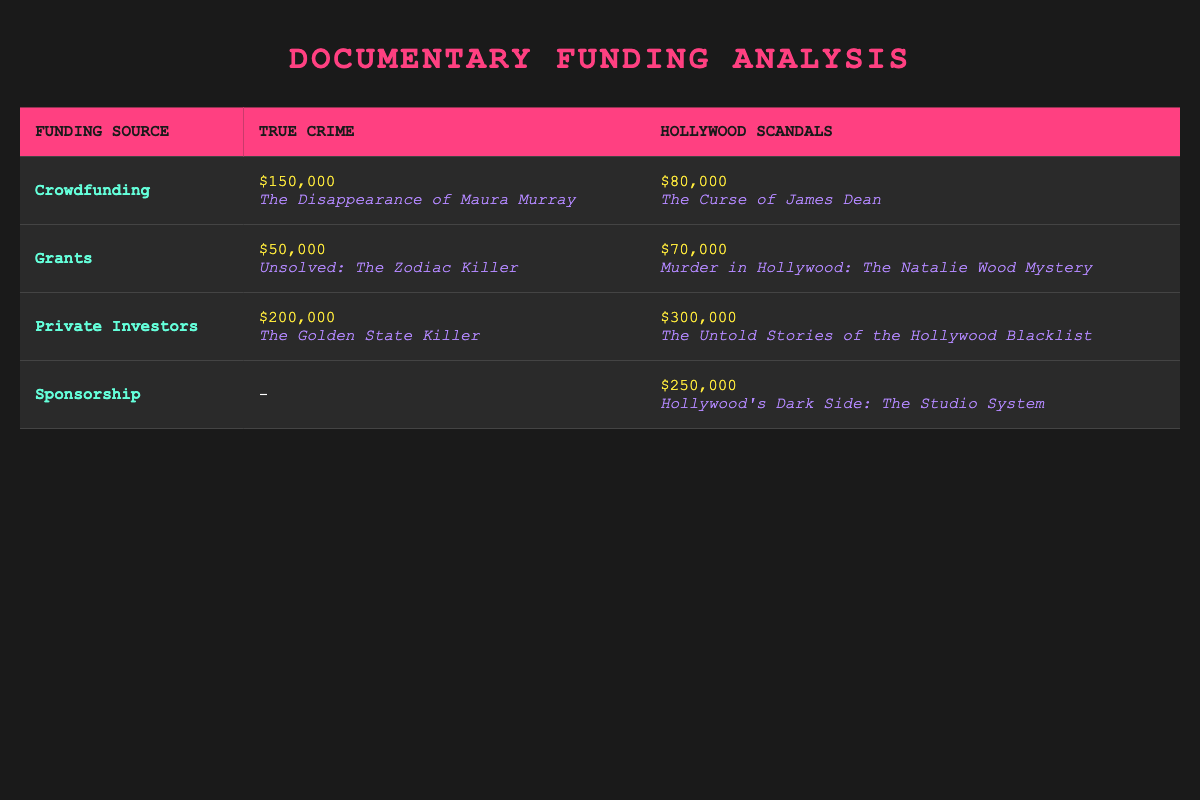What is the total funding received from private investors for true crime documentaries? The funding from private investors for true crime is listed as $200,000 in the table.
Answer: 200000 Which type of funding produced the highest total amount for Hollywood scandal documentaries? Sponsorship contributed $250,000, while private investors contributed $300,000; therefore, private investors produced the highest total amount.
Answer: Private Investors Is there a documentary funded by grants in the true crime category? Yes, the table lists "Unsolved: The Zodiac Killer," which has received $50,000 from grants in the true crime category.
Answer: Yes What is the difference in total funding amounts between crowdfunding for true crime and Hollywood scandals? True crime crowdfunding totals $150,000, and Hollywood scandals crowdfunding totals $80,000; the difference is $150,000 - $80,000 = $70,000.
Answer: 70000 Calculate the average funding amount received from grants across both documentary types. The grants for true crime is $50,000, and for Hollywood scandals is $70,000; they add up to $50,000 + $70,000 = $120,000 over 2 projects, so the average is $120,000 / 2 = $60,000.
Answer: 60000 Which documentary had the highest amount funded overall? The highest funding amount comes from "The Untold Stories of the Hollywood Blacklist" at $300,000, funded by private investors.
Answer: The Untold Stories of the Hollywood Blacklist Was there any documentary that did not receive crowdfunding? Yes, "The Untold Stories of the Hollywood Blacklist" and "Hollywood's Dark Side: The Studio System" were funded by private investors and sponsorship, respectively, and did not receive crowdfunding.
Answer: Yes What is the total funding amount for all Hollywood scandals projects listed in the table? The total funding for Hollywood scandals is $80,000 (crowdfunding) + $70,000 (grants) + $300,000 (private investors) + $250,000 (sponsorship) = $700,000.
Answer: 700000 Which funding source was utilized for the documentary "The Golden State Killer"? The documentary "The Golden State Killer" received $200,000 from private investors, as indicated in the table.
Answer: Private Investors 